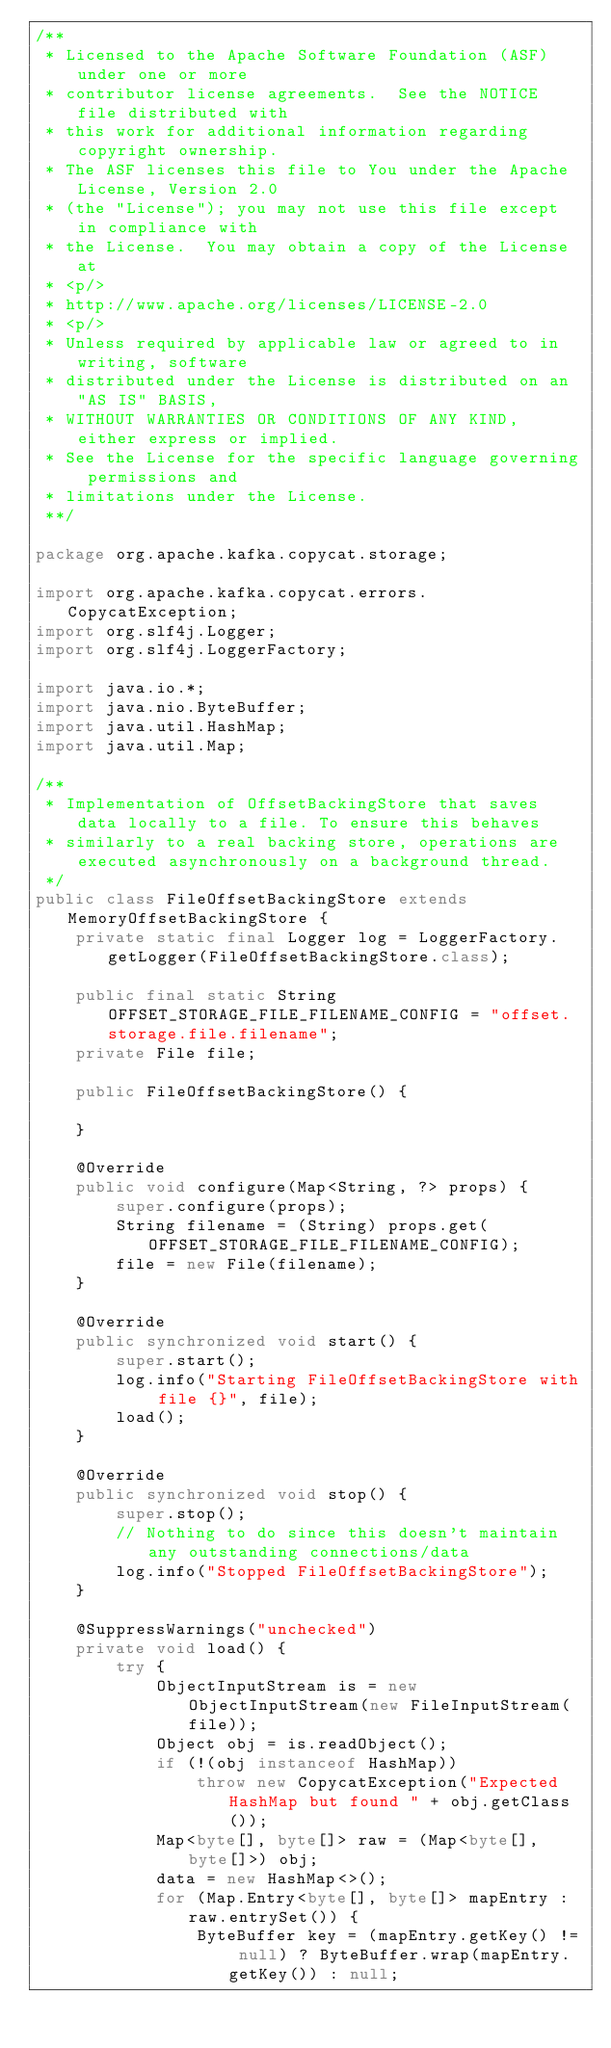Convert code to text. <code><loc_0><loc_0><loc_500><loc_500><_Java_>/**
 * Licensed to the Apache Software Foundation (ASF) under one or more
 * contributor license agreements.  See the NOTICE file distributed with
 * this work for additional information regarding copyright ownership.
 * The ASF licenses this file to You under the Apache License, Version 2.0
 * (the "License"); you may not use this file except in compliance with
 * the License.  You may obtain a copy of the License at
 * <p/>
 * http://www.apache.org/licenses/LICENSE-2.0
 * <p/>
 * Unless required by applicable law or agreed to in writing, software
 * distributed under the License is distributed on an "AS IS" BASIS,
 * WITHOUT WARRANTIES OR CONDITIONS OF ANY KIND, either express or implied.
 * See the License for the specific language governing permissions and
 * limitations under the License.
 **/

package org.apache.kafka.copycat.storage;

import org.apache.kafka.copycat.errors.CopycatException;
import org.slf4j.Logger;
import org.slf4j.LoggerFactory;

import java.io.*;
import java.nio.ByteBuffer;
import java.util.HashMap;
import java.util.Map;

/**
 * Implementation of OffsetBackingStore that saves data locally to a file. To ensure this behaves
 * similarly to a real backing store, operations are executed asynchronously on a background thread.
 */
public class FileOffsetBackingStore extends MemoryOffsetBackingStore {
    private static final Logger log = LoggerFactory.getLogger(FileOffsetBackingStore.class);

    public final static String OFFSET_STORAGE_FILE_FILENAME_CONFIG = "offset.storage.file.filename";
    private File file;

    public FileOffsetBackingStore() {

    }

    @Override
    public void configure(Map<String, ?> props) {
        super.configure(props);
        String filename = (String) props.get(OFFSET_STORAGE_FILE_FILENAME_CONFIG);
        file = new File(filename);
    }

    @Override
    public synchronized void start() {
        super.start();
        log.info("Starting FileOffsetBackingStore with file {}", file);
        load();
    }

    @Override
    public synchronized void stop() {
        super.stop();
        // Nothing to do since this doesn't maintain any outstanding connections/data
        log.info("Stopped FileOffsetBackingStore");
    }

    @SuppressWarnings("unchecked")
    private void load() {
        try {
            ObjectInputStream is = new ObjectInputStream(new FileInputStream(file));
            Object obj = is.readObject();
            if (!(obj instanceof HashMap))
                throw new CopycatException("Expected HashMap but found " + obj.getClass());
            Map<byte[], byte[]> raw = (Map<byte[], byte[]>) obj;
            data = new HashMap<>();
            for (Map.Entry<byte[], byte[]> mapEntry : raw.entrySet()) {
                ByteBuffer key = (mapEntry.getKey() != null) ? ByteBuffer.wrap(mapEntry.getKey()) : null;</code> 